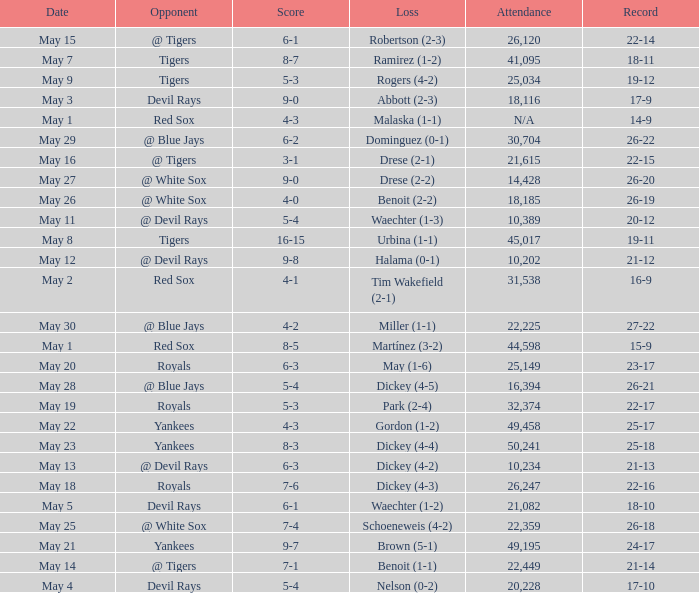What was the record at the game attended by 10,389? 20-12. 